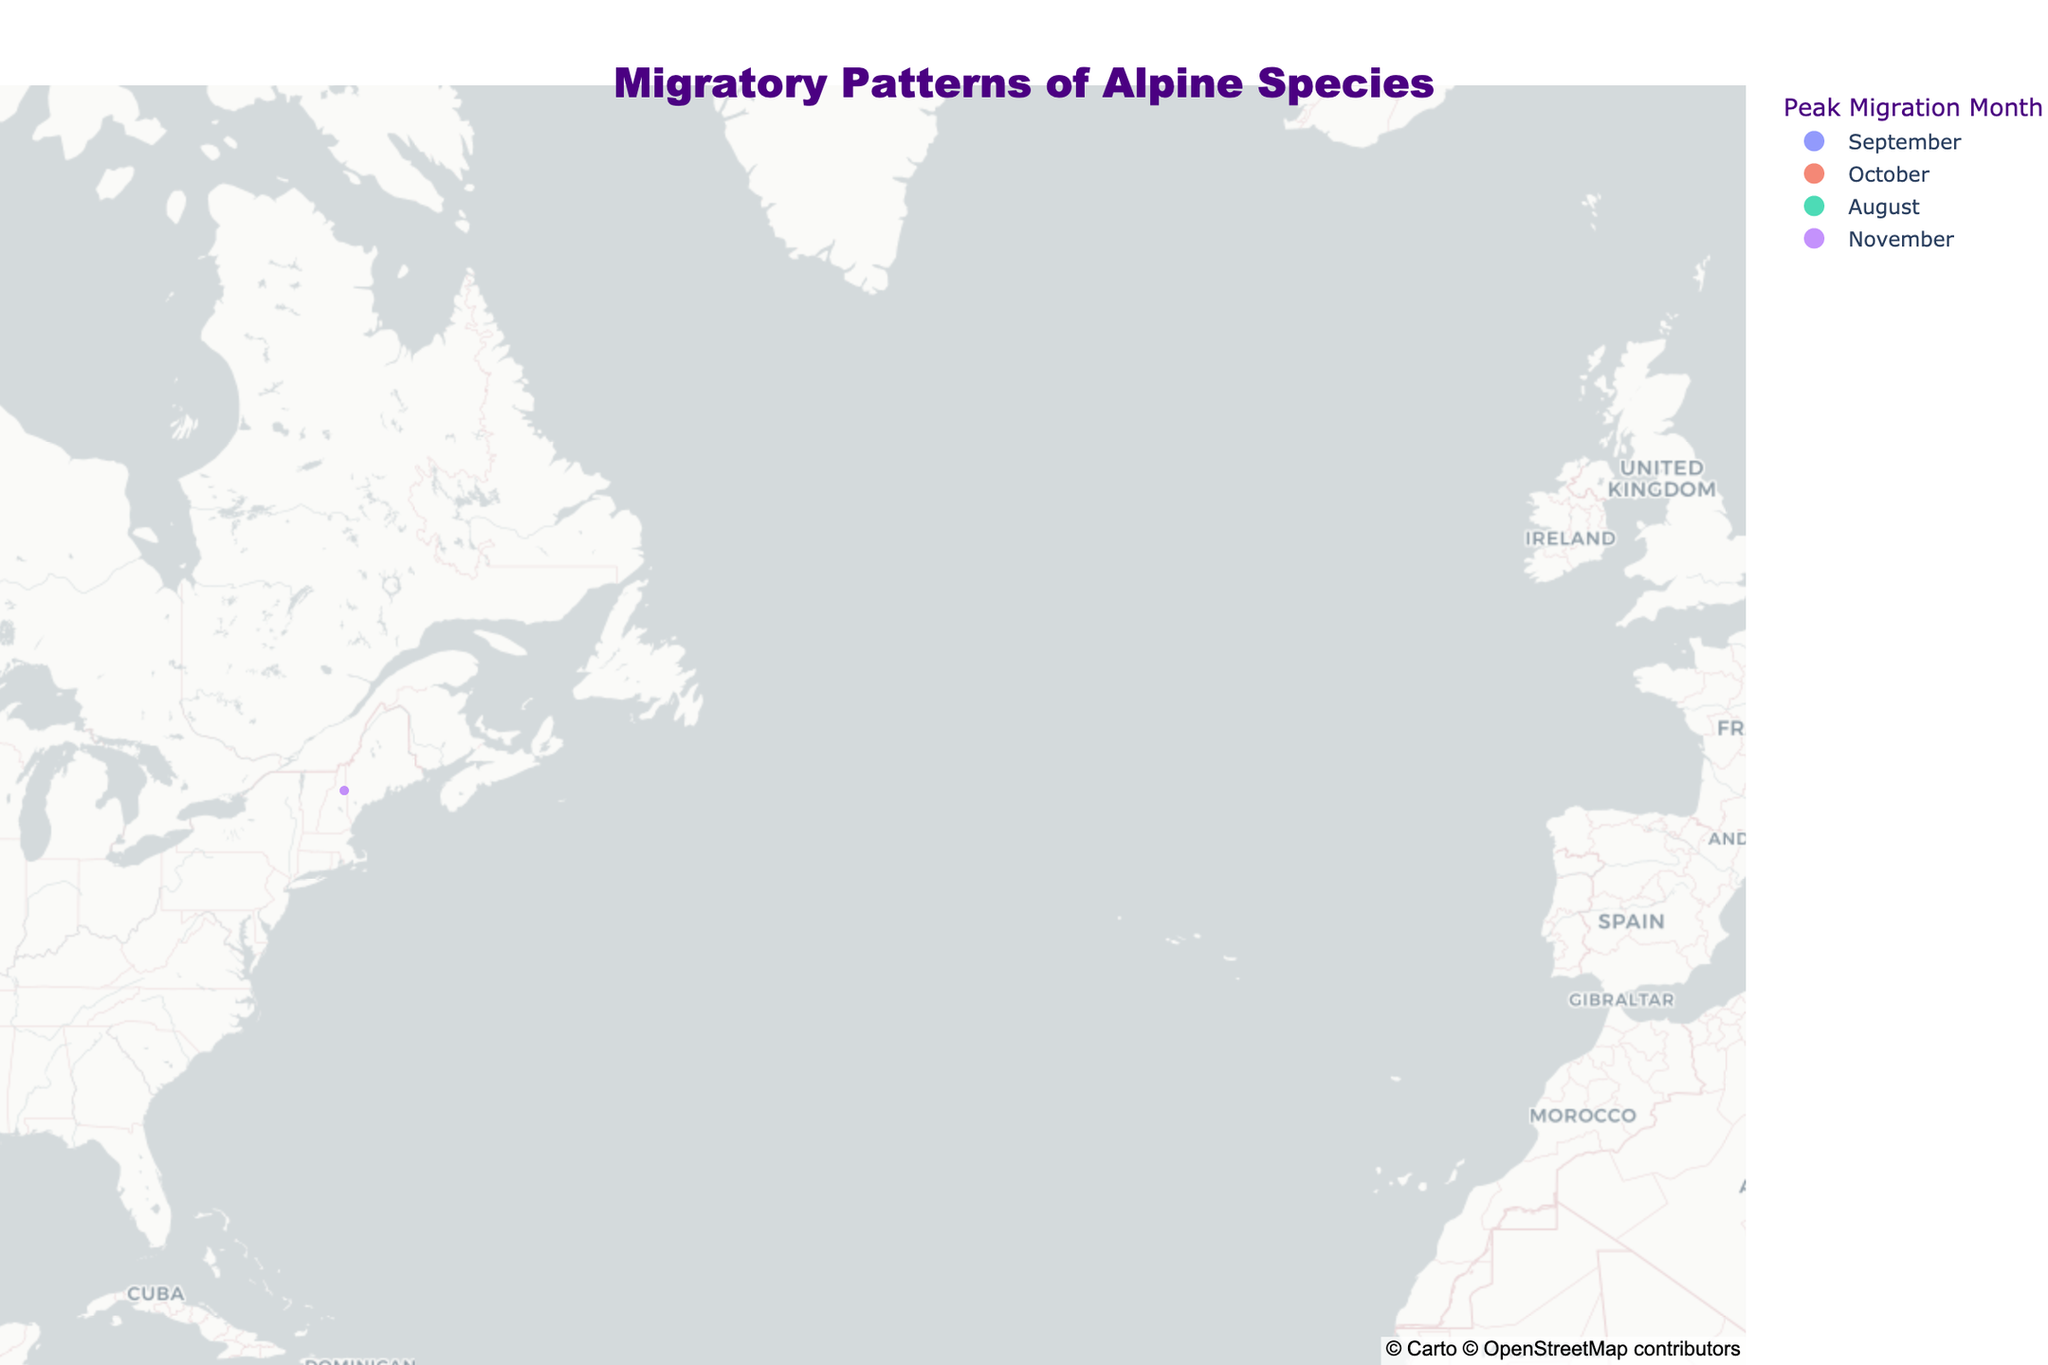What's the title of the plot? The title is normally displayed at the top of a plot and typically summarizes what the plot is about. In this plot, it is "Migratory Patterns of Alpine Species".
Answer: Migratory Patterns of Alpine Species Which species have their peak migration in September? By looking at the color linked to 'Peak Migration Month' and matching it to September, we see that the Alpine Marmot, Mountain Hare, and Golden Eagle peak in September.
Answer: Alpine Marmot, Mountain Hare, Golden Eagle What is the species with the maximum migration distance, and what's its peak migration month? By observing the sizes of the data points and identifying the largest one, we see the Golden Eagle, with a peak migration month in September, has the maximum migration distance.
Answer: Golden Eagle, September Which species migrates the shortest distance, and in what month? Looking at the smallest data points and cross-referencing with the migration distance, the Pika migrates the shortest distance of 2 km, peaking in August.
Answer: Pika, August Among species with peak migration in October, which one migrates the furthest? For species with peak migration in October, comparing their data point sizes, the Ptarmigan migrates the furthest with a distance of 30 km.
Answer: Ptarmigan How many species are plotted on the map? Each data point represents a species. Counting these data points on the map gives the total number of species. Nine species are plotted.
Answer: 9 Which species has a migration distance greater than 10 km but less than 20 km, and what is its peak migration month? Reviewing the data points' sizes within the specified range, the Snowshoe Hare has a migration distance of 10 km and peaks in November.
Answer: Snowshoe Hare, November Is there any species with its peak migration month in August? If yes, which one? Observing the colors linked to the 'Peak Migration Month' and finding the one that matches August, the Pika peaks in August.
Answer: Pika What is the average migration distance of species with their peak migration month in October? First, identify species peaking in October: Yellow-bellied Marmot, Ibex, Ptarmigan. Then sum their distances (3+20+30) = 53 km and divide by the number of species (3). The average migration distance is 53/3 ≈ 17.7 km.
Answer: 17.7 km Which region has the highest concentration of species, and what might this indicate? By observing the map and spotting where most species are located, the European Alps region (around latitudes 45-47) has the highest concentration, potentially indicating a rich ecological niche.
Answer: European Alps 